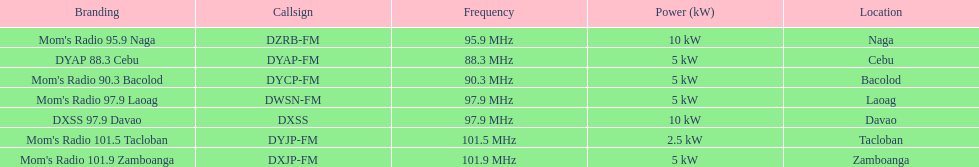What are the total number of radio stations on this list? 7. 